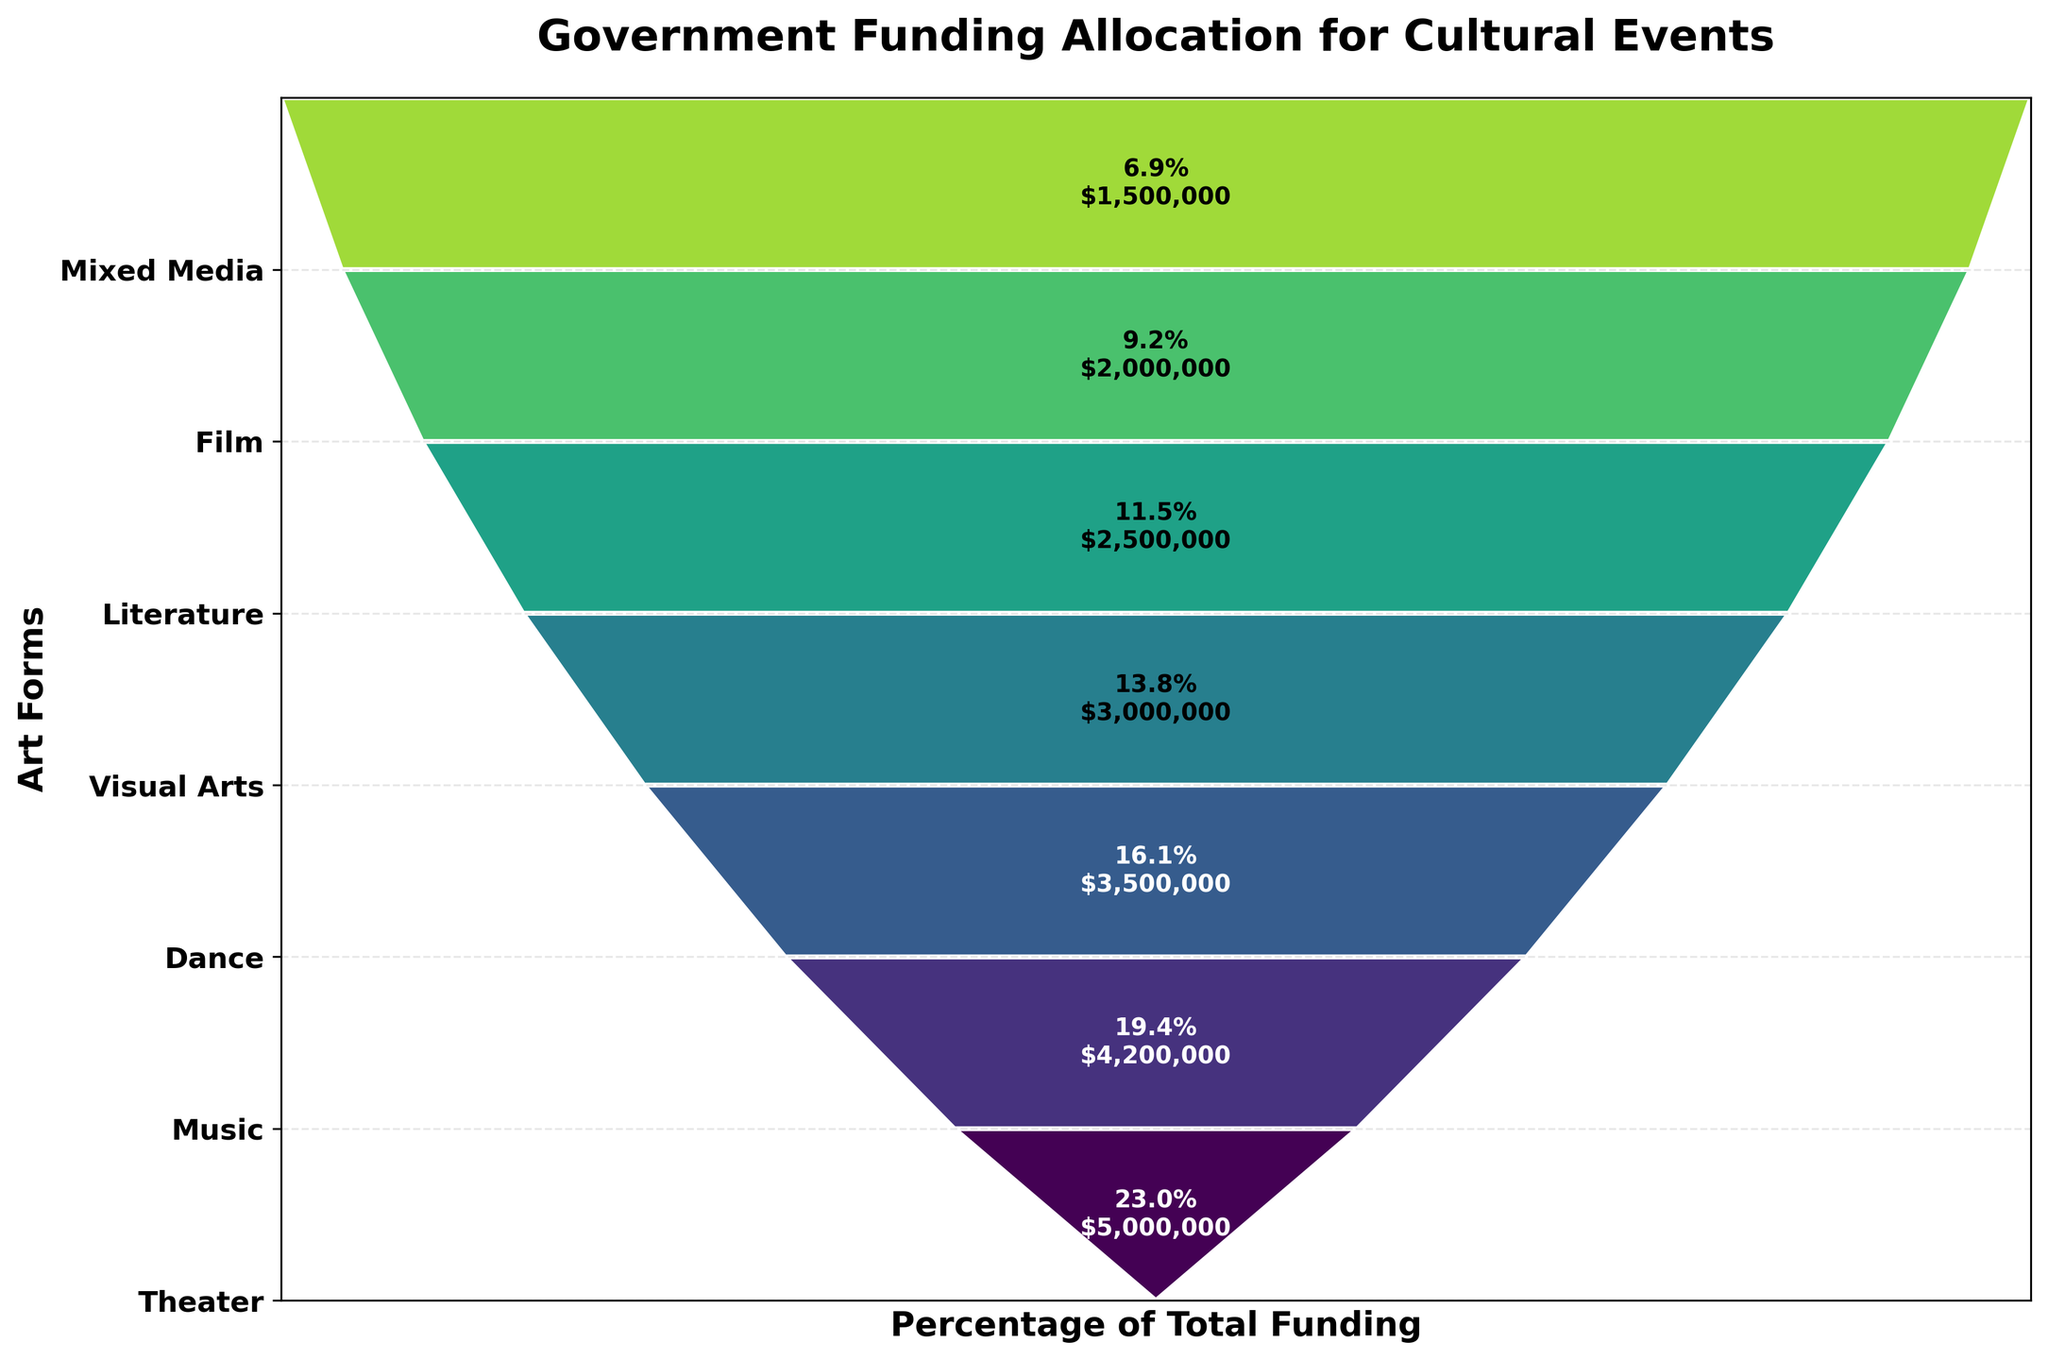Which art form received the highest funding? To identify the art form with the highest funding, look at the top segment of the funnel chart, which represents the largest allocation.
Answer: Theater What percentage of the total funding is allocated to music? The plot provides percentage information for each art form. Look at the segment corresponding to music and read the percentage label, which states the proportion of the funding.
Answer: 17.5% How much total funding was allocated to Visual Arts and Literature combined? Find the funding amounts for Visual Arts and Literature from the labels within the chart. Visual Arts received $3,000,000, and Literature received $2,500,000. Add these amounts together: $3,000,000 + $2,500,000.
Answer: $5,500,000 Which art form received less funding: Dance or Film? To compare the funding amounts for Dance and Film, look at their segments on the funnel chart. Dance is higher up in the funnel with $3,500,000, and Film is lower with $2,000,000.
Answer: Film How many art forms have funding allocations between $2,000,000 and $4,000,000? To determine the number of art forms falling within this range, count the segments that represent amounts between $2,000,000 and $4,000,000. Specifically, these are Dance ($3,500,000), Visual Arts ($3,000,000), and Literature ($2,500,000).
Answer: 3 By what percentage did the funding for Theater exceed the funding for Mixed Media? Find the funding amounts for Theater ($5,000,000) and Mixed Media ($1,500,000). Calculate the difference ($5,000,000 - $1,500,000 = $3,500,000) and then compute the percentage relative to Mixed Media’s amount: ($3,500,000 / $1,500,000) * 100%.
Answer: 233.3% What is the cumulative percentage of funding allocated to the top three art forms? Find the percentages for the top three art forms: Theater, Music, and Dance. Add these percentages together: Theater (20.8%) + Music (17.5%) + Dance (14.6%).
Answer: 52.9% Is the funding allocation for Film greater than the combined funding of Mixed Media and Literature? Compare Film’s funding ($2,000,000) to the combined funding of Mixed Media and Literature ($1,500,000 + $2,500,000 = $4,000,000). Film’s funding ($2,000,000) is less.
Answer: No 